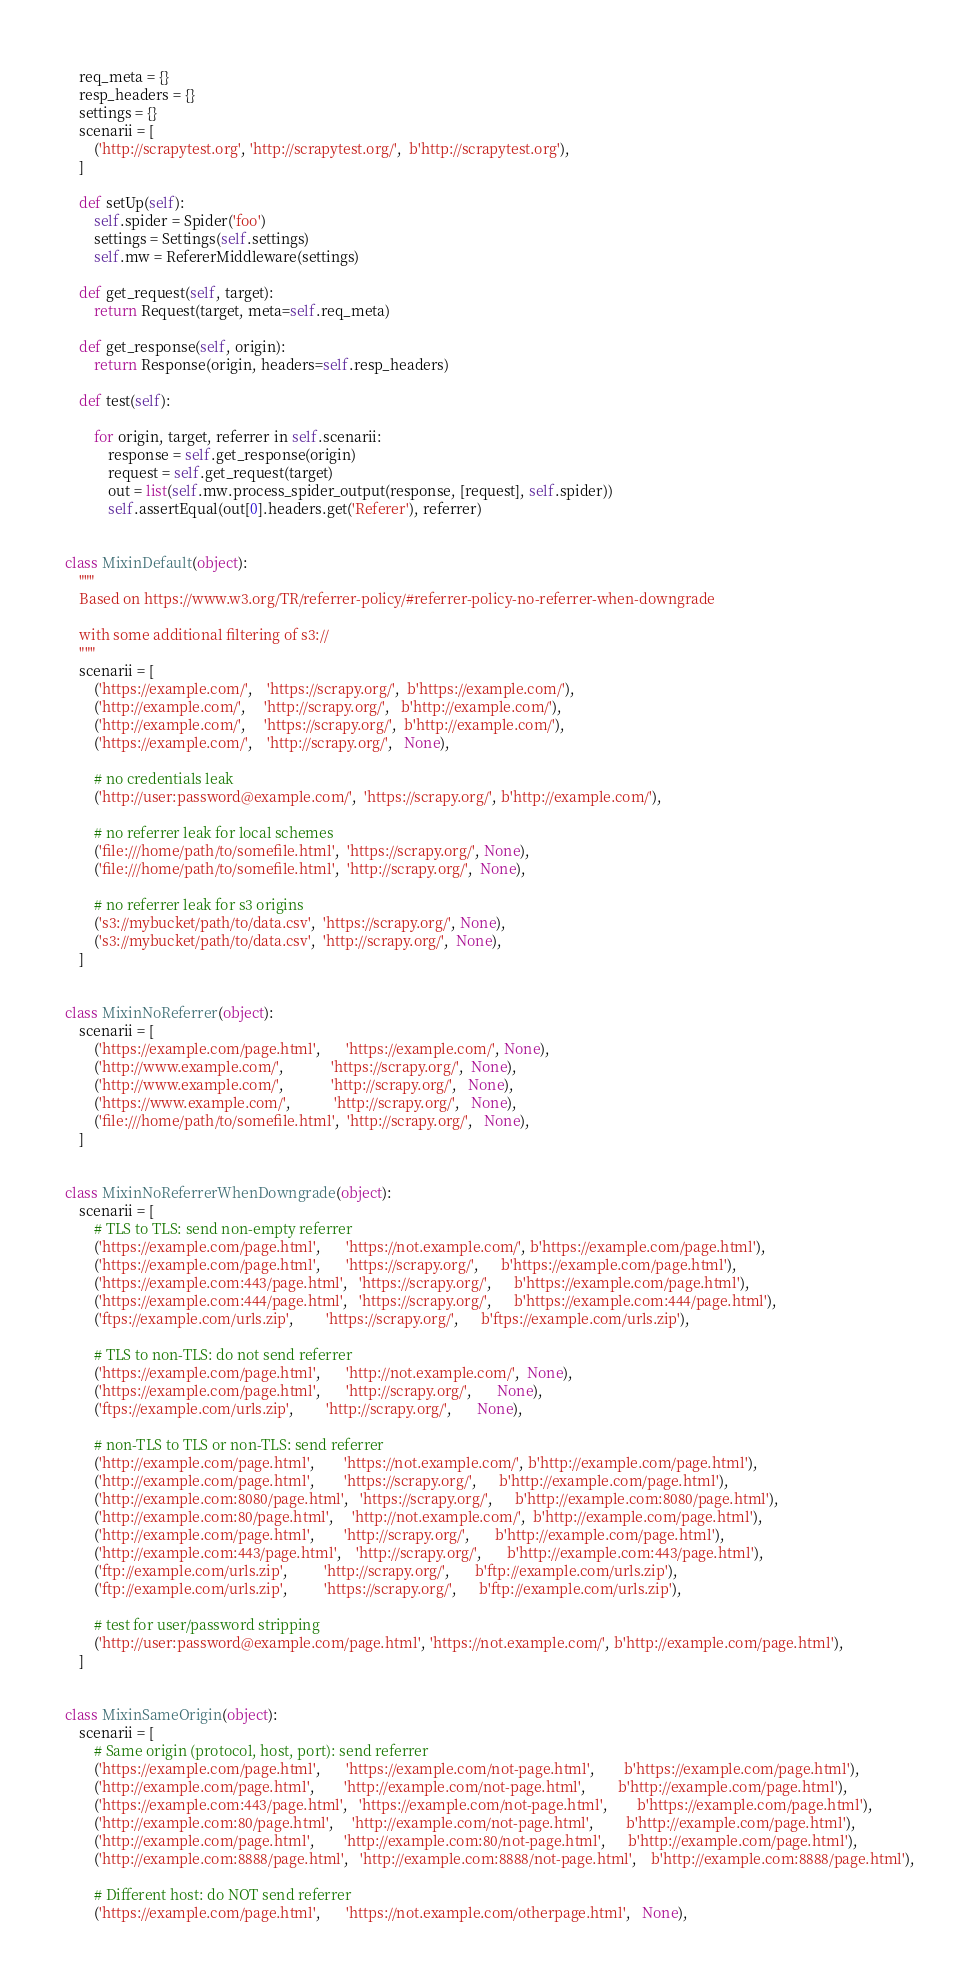Convert code to text. <code><loc_0><loc_0><loc_500><loc_500><_Python_>    req_meta = {}
    resp_headers = {}
    settings = {}
    scenarii = [
        ('http://scrapytest.org', 'http://scrapytest.org/',  b'http://scrapytest.org'),
    ]

    def setUp(self):
        self.spider = Spider('foo')
        settings = Settings(self.settings)
        self.mw = RefererMiddleware(settings)

    def get_request(self, target):
        return Request(target, meta=self.req_meta)

    def get_response(self, origin):
        return Response(origin, headers=self.resp_headers)

    def test(self):

        for origin, target, referrer in self.scenarii:
            response = self.get_response(origin)
            request = self.get_request(target)
            out = list(self.mw.process_spider_output(response, [request], self.spider))
            self.assertEqual(out[0].headers.get('Referer'), referrer)


class MixinDefault(object):
    """
    Based on https://www.w3.org/TR/referrer-policy/#referrer-policy-no-referrer-when-downgrade

    with some additional filtering of s3://
    """
    scenarii = [
        ('https://example.com/',    'https://scrapy.org/',  b'https://example.com/'),
        ('http://example.com/',     'http://scrapy.org/',   b'http://example.com/'),
        ('http://example.com/',     'https://scrapy.org/',  b'http://example.com/'),
        ('https://example.com/',    'http://scrapy.org/',   None),

        # no credentials leak
        ('http://user:password@example.com/',  'https://scrapy.org/', b'http://example.com/'),

        # no referrer leak for local schemes
        ('file:///home/path/to/somefile.html',  'https://scrapy.org/', None),
        ('file:///home/path/to/somefile.html',  'http://scrapy.org/',  None),

        # no referrer leak for s3 origins
        ('s3://mybucket/path/to/data.csv',  'https://scrapy.org/', None),
        ('s3://mybucket/path/to/data.csv',  'http://scrapy.org/',  None),
    ]


class MixinNoReferrer(object):
    scenarii = [
        ('https://example.com/page.html',       'https://example.com/', None),
        ('http://www.example.com/',             'https://scrapy.org/',  None),
        ('http://www.example.com/',             'http://scrapy.org/',   None),
        ('https://www.example.com/',            'http://scrapy.org/',   None),
        ('file:///home/path/to/somefile.html',  'http://scrapy.org/',   None),
    ]


class MixinNoReferrerWhenDowngrade(object):
    scenarii = [
        # TLS to TLS: send non-empty referrer
        ('https://example.com/page.html',       'https://not.example.com/', b'https://example.com/page.html'),
        ('https://example.com/page.html',       'https://scrapy.org/',      b'https://example.com/page.html'),
        ('https://example.com:443/page.html',   'https://scrapy.org/',      b'https://example.com/page.html'),
        ('https://example.com:444/page.html',   'https://scrapy.org/',      b'https://example.com:444/page.html'),
        ('ftps://example.com/urls.zip',         'https://scrapy.org/',      b'ftps://example.com/urls.zip'),

        # TLS to non-TLS: do not send referrer
        ('https://example.com/page.html',       'http://not.example.com/',  None),
        ('https://example.com/page.html',       'http://scrapy.org/',       None),
        ('ftps://example.com/urls.zip',         'http://scrapy.org/',       None),

        # non-TLS to TLS or non-TLS: send referrer
        ('http://example.com/page.html',        'https://not.example.com/', b'http://example.com/page.html'),
        ('http://example.com/page.html',        'https://scrapy.org/',      b'http://example.com/page.html'),
        ('http://example.com:8080/page.html',   'https://scrapy.org/',      b'http://example.com:8080/page.html'),
        ('http://example.com:80/page.html',     'http://not.example.com/',  b'http://example.com/page.html'),
        ('http://example.com/page.html',        'http://scrapy.org/',       b'http://example.com/page.html'),
        ('http://example.com:443/page.html',    'http://scrapy.org/',       b'http://example.com:443/page.html'),
        ('ftp://example.com/urls.zip',          'http://scrapy.org/',       b'ftp://example.com/urls.zip'),
        ('ftp://example.com/urls.zip',          'https://scrapy.org/',      b'ftp://example.com/urls.zip'),

        # test for user/password stripping
        ('http://user:password@example.com/page.html', 'https://not.example.com/', b'http://example.com/page.html'),
    ]


class MixinSameOrigin(object):
    scenarii = [
        # Same origin (protocol, host, port): send referrer
        ('https://example.com/page.html',       'https://example.com/not-page.html',        b'https://example.com/page.html'),
        ('http://example.com/page.html',        'http://example.com/not-page.html',         b'http://example.com/page.html'),
        ('https://example.com:443/page.html',   'https://example.com/not-page.html',        b'https://example.com/page.html'),
        ('http://example.com:80/page.html',     'http://example.com/not-page.html',         b'http://example.com/page.html'),
        ('http://example.com/page.html',        'http://example.com:80/not-page.html',      b'http://example.com/page.html'),
        ('http://example.com:8888/page.html',   'http://example.com:8888/not-page.html',    b'http://example.com:8888/page.html'),

        # Different host: do NOT send referrer
        ('https://example.com/page.html',       'https://not.example.com/otherpage.html',   None),</code> 